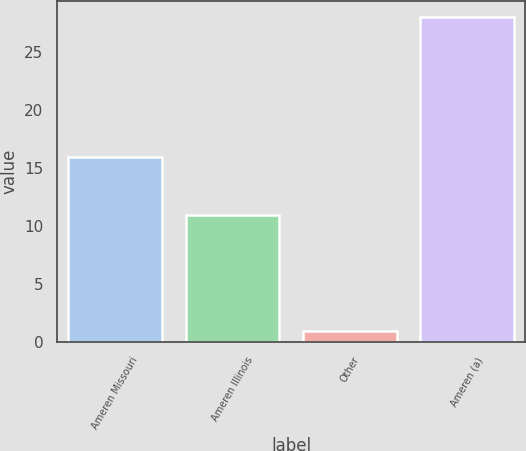Convert chart to OTSL. <chart><loc_0><loc_0><loc_500><loc_500><bar_chart><fcel>Ameren Missouri<fcel>Ameren Illinois<fcel>Other<fcel>Ameren (a)<nl><fcel>16<fcel>11<fcel>1<fcel>28<nl></chart> 